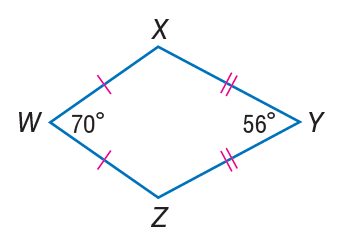Question: Find m \angle X.
Choices:
A. 14
B. 56
C. 70
D. 117
Answer with the letter. Answer: D 